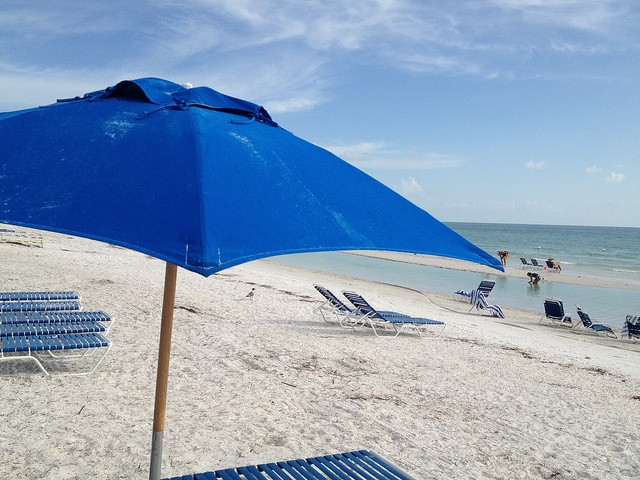Describe the objects in this image and their specific colors. I can see umbrella in gray, darkblue, blue, and navy tones, bench in gray, blue, navy, darkblue, and darkgray tones, chair in gray, darkgray, and lightgray tones, bench in gray, darkgray, and lightgray tones, and chair in gray, blue, navy, darkblue, and darkgray tones in this image. 